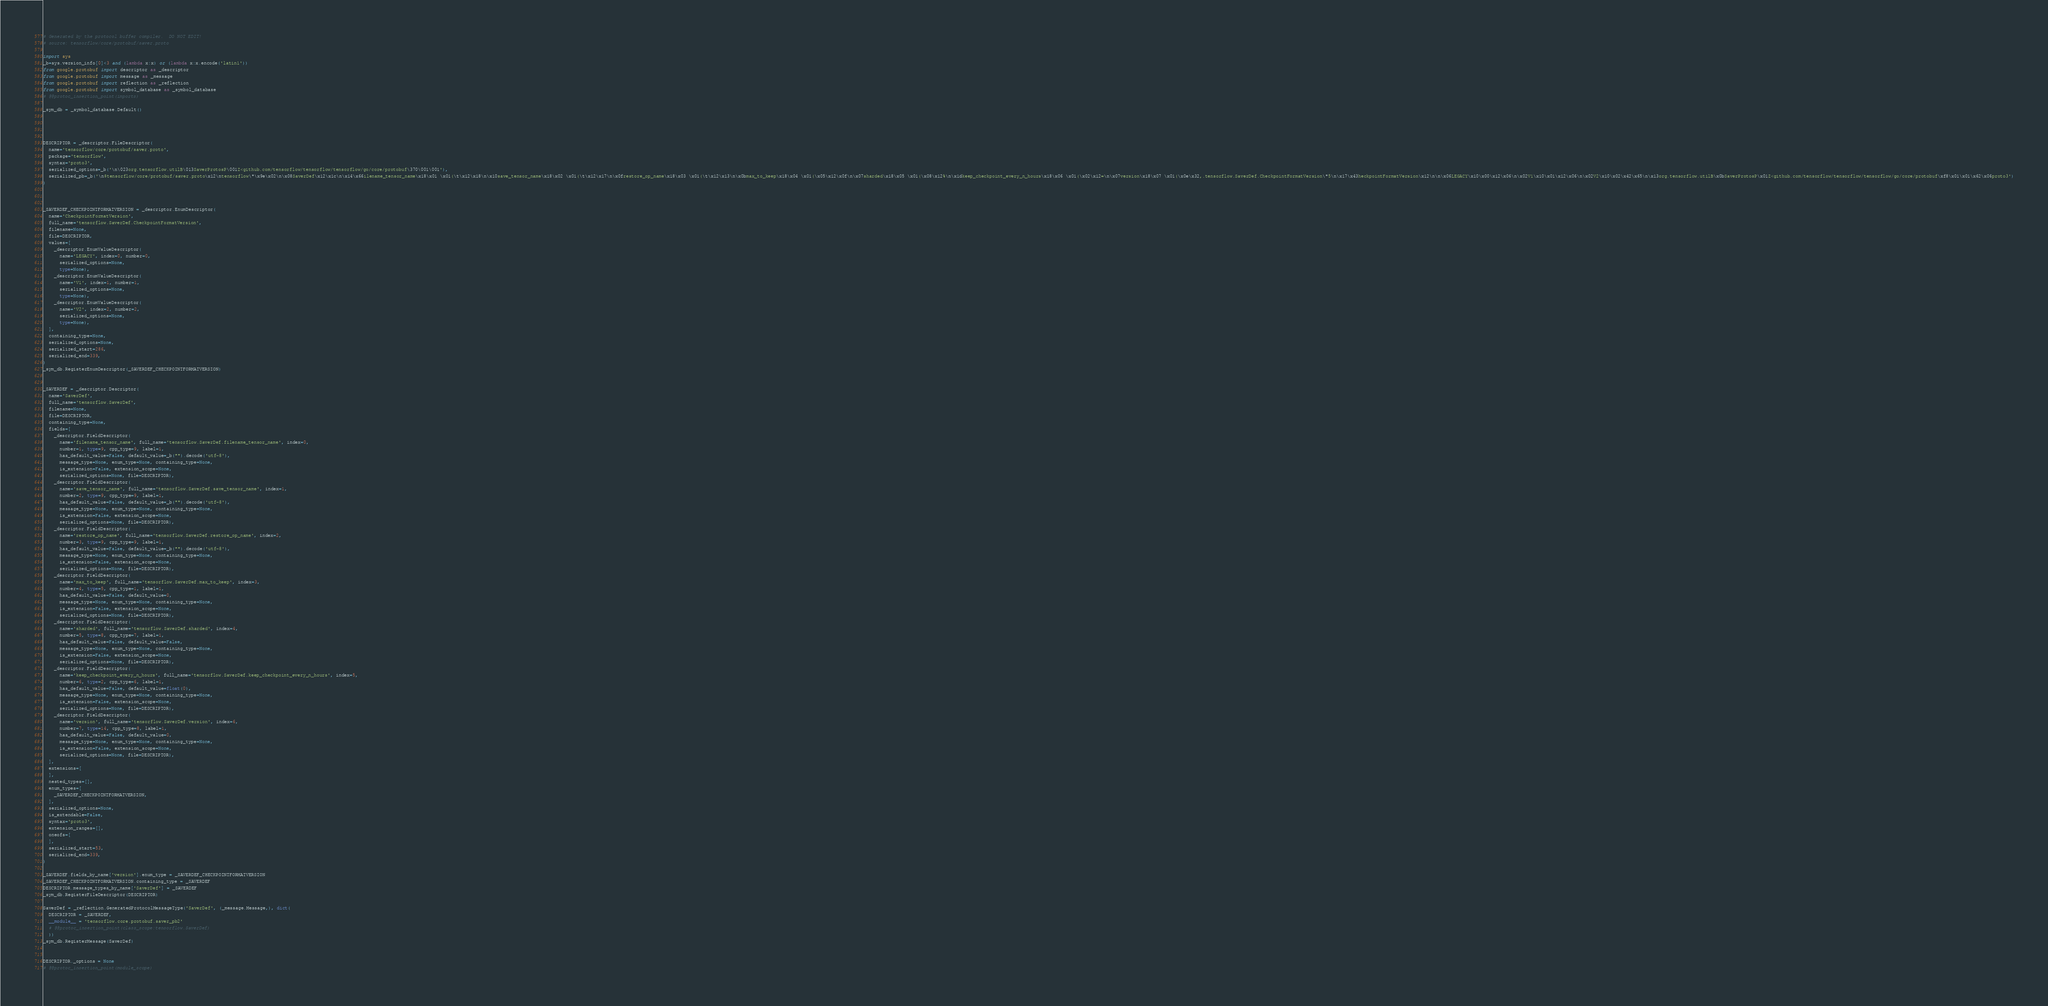Convert code to text. <code><loc_0><loc_0><loc_500><loc_500><_Python_># Generated by the protocol buffer compiler.  DO NOT EDIT!
# source: tensorflow/core/protobuf/saver.proto

import sys
_b=sys.version_info[0]<3 and (lambda x:x) or (lambda x:x.encode('latin1'))
from google.protobuf import descriptor as _descriptor
from google.protobuf import message as _message
from google.protobuf import reflection as _reflection
from google.protobuf import symbol_database as _symbol_database
# @@protoc_insertion_point(imports)

_sym_db = _symbol_database.Default()




DESCRIPTOR = _descriptor.FileDescriptor(
  name='tensorflow/core/protobuf/saver.proto',
  package='tensorflow',
  syntax='proto3',
  serialized_options=_b('\n\023org.tensorflow.utilB\013SaverProtosP\001Z<github.com/tensorflow/tensorflow/tensorflow/go/core/protobuf\370\001\001'),
  serialized_pb=_b('\n$tensorflow/core/protobuf/saver.proto\x12\ntensorflow\"\x9e\x02\n\x08SaverDef\x12\x1c\n\x14\x66ilename_tensor_name\x18\x01 \x01(\t\x12\x18\n\x10save_tensor_name\x18\x02 \x01(\t\x12\x17\n\x0frestore_op_name\x18\x03 \x01(\t\x12\x13\n\x0bmax_to_keep\x18\x04 \x01(\x05\x12\x0f\n\x07sharded\x18\x05 \x01(\x08\x12%\n\x1dkeep_checkpoint_every_n_hours\x18\x06 \x01(\x02\x12=\n\x07version\x18\x07 \x01(\x0e\x32,.tensorflow.SaverDef.CheckpointFormatVersion\"5\n\x17\x43heckpointFormatVersion\x12\n\n\x06LEGACY\x10\x00\x12\x06\n\x02V1\x10\x01\x12\x06\n\x02V2\x10\x02\x42\x65\n\x13org.tensorflow.utilB\x0bSaverProtosP\x01Z<github.com/tensorflow/tensorflow/tensorflow/go/core/protobuf\xf8\x01\x01\x62\x06proto3')
)



_SAVERDEF_CHECKPOINTFORMATVERSION = _descriptor.EnumDescriptor(
  name='CheckpointFormatVersion',
  full_name='tensorflow.SaverDef.CheckpointFormatVersion',
  filename=None,
  file=DESCRIPTOR,
  values=[
    _descriptor.EnumValueDescriptor(
      name='LEGACY', index=0, number=0,
      serialized_options=None,
      type=None),
    _descriptor.EnumValueDescriptor(
      name='V1', index=1, number=1,
      serialized_options=None,
      type=None),
    _descriptor.EnumValueDescriptor(
      name='V2', index=2, number=2,
      serialized_options=None,
      type=None),
  ],
  containing_type=None,
  serialized_options=None,
  serialized_start=286,
  serialized_end=339,
)
_sym_db.RegisterEnumDescriptor(_SAVERDEF_CHECKPOINTFORMATVERSION)


_SAVERDEF = _descriptor.Descriptor(
  name='SaverDef',
  full_name='tensorflow.SaverDef',
  filename=None,
  file=DESCRIPTOR,
  containing_type=None,
  fields=[
    _descriptor.FieldDescriptor(
      name='filename_tensor_name', full_name='tensorflow.SaverDef.filename_tensor_name', index=0,
      number=1, type=9, cpp_type=9, label=1,
      has_default_value=False, default_value=_b("").decode('utf-8'),
      message_type=None, enum_type=None, containing_type=None,
      is_extension=False, extension_scope=None,
      serialized_options=None, file=DESCRIPTOR),
    _descriptor.FieldDescriptor(
      name='save_tensor_name', full_name='tensorflow.SaverDef.save_tensor_name', index=1,
      number=2, type=9, cpp_type=9, label=1,
      has_default_value=False, default_value=_b("").decode('utf-8'),
      message_type=None, enum_type=None, containing_type=None,
      is_extension=False, extension_scope=None,
      serialized_options=None, file=DESCRIPTOR),
    _descriptor.FieldDescriptor(
      name='restore_op_name', full_name='tensorflow.SaverDef.restore_op_name', index=2,
      number=3, type=9, cpp_type=9, label=1,
      has_default_value=False, default_value=_b("").decode('utf-8'),
      message_type=None, enum_type=None, containing_type=None,
      is_extension=False, extension_scope=None,
      serialized_options=None, file=DESCRIPTOR),
    _descriptor.FieldDescriptor(
      name='max_to_keep', full_name='tensorflow.SaverDef.max_to_keep', index=3,
      number=4, type=5, cpp_type=1, label=1,
      has_default_value=False, default_value=0,
      message_type=None, enum_type=None, containing_type=None,
      is_extension=False, extension_scope=None,
      serialized_options=None, file=DESCRIPTOR),
    _descriptor.FieldDescriptor(
      name='sharded', full_name='tensorflow.SaverDef.sharded', index=4,
      number=5, type=8, cpp_type=7, label=1,
      has_default_value=False, default_value=False,
      message_type=None, enum_type=None, containing_type=None,
      is_extension=False, extension_scope=None,
      serialized_options=None, file=DESCRIPTOR),
    _descriptor.FieldDescriptor(
      name='keep_checkpoint_every_n_hours', full_name='tensorflow.SaverDef.keep_checkpoint_every_n_hours', index=5,
      number=6, type=2, cpp_type=6, label=1,
      has_default_value=False, default_value=float(0),
      message_type=None, enum_type=None, containing_type=None,
      is_extension=False, extension_scope=None,
      serialized_options=None, file=DESCRIPTOR),
    _descriptor.FieldDescriptor(
      name='version', full_name='tensorflow.SaverDef.version', index=6,
      number=7, type=14, cpp_type=8, label=1,
      has_default_value=False, default_value=0,
      message_type=None, enum_type=None, containing_type=None,
      is_extension=False, extension_scope=None,
      serialized_options=None, file=DESCRIPTOR),
  ],
  extensions=[
  ],
  nested_types=[],
  enum_types=[
    _SAVERDEF_CHECKPOINTFORMATVERSION,
  ],
  serialized_options=None,
  is_extendable=False,
  syntax='proto3',
  extension_ranges=[],
  oneofs=[
  ],
  serialized_start=53,
  serialized_end=339,
)

_SAVERDEF.fields_by_name['version'].enum_type = _SAVERDEF_CHECKPOINTFORMATVERSION
_SAVERDEF_CHECKPOINTFORMATVERSION.containing_type = _SAVERDEF
DESCRIPTOR.message_types_by_name['SaverDef'] = _SAVERDEF
_sym_db.RegisterFileDescriptor(DESCRIPTOR)

SaverDef = _reflection.GeneratedProtocolMessageType('SaverDef', (_message.Message,), dict(
  DESCRIPTOR = _SAVERDEF,
  __module__ = 'tensorflow.core.protobuf.saver_pb2'
  # @@protoc_insertion_point(class_scope:tensorflow.SaverDef)
  ))
_sym_db.RegisterMessage(SaverDef)


DESCRIPTOR._options = None
# @@protoc_insertion_point(module_scope)
</code> 